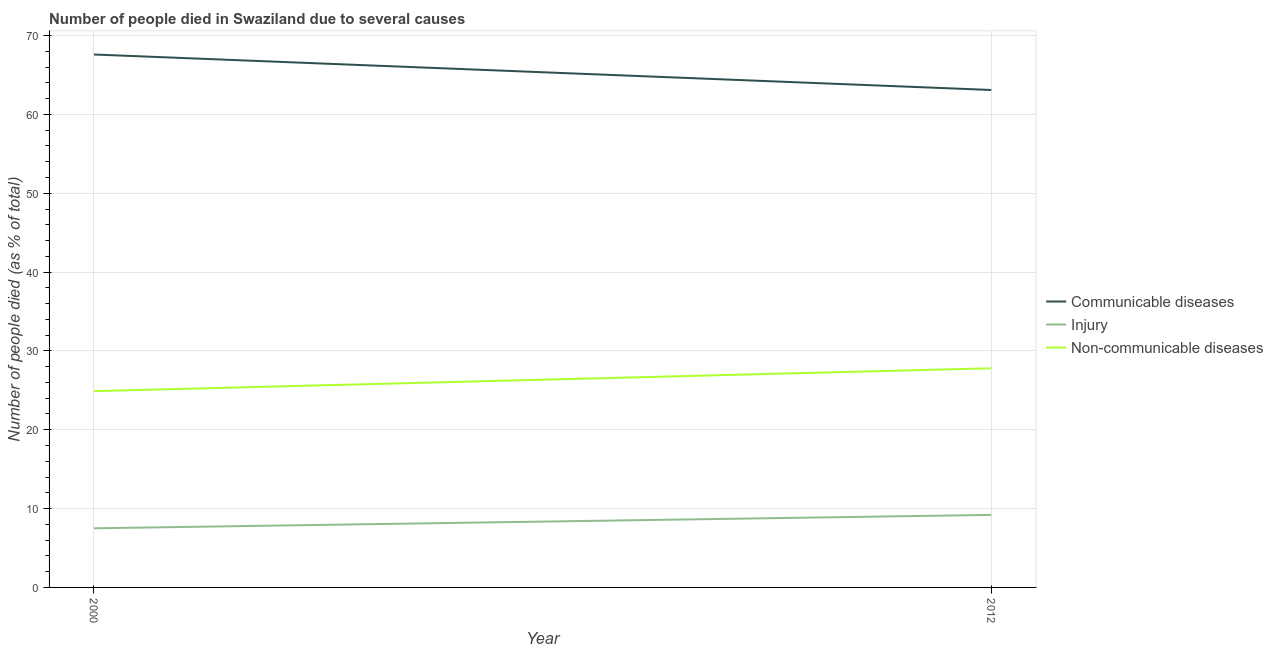Does the line corresponding to number of people who died of injury intersect with the line corresponding to number of people who died of communicable diseases?
Make the answer very short. No. Across all years, what is the maximum number of people who died of communicable diseases?
Provide a succinct answer. 67.6. Across all years, what is the minimum number of people who died of communicable diseases?
Provide a short and direct response. 63.1. In which year was the number of people who died of communicable diseases maximum?
Offer a very short reply. 2000. What is the total number of people who dies of non-communicable diseases in the graph?
Your response must be concise. 52.7. What is the difference between the number of people who died of communicable diseases in 2000 and that in 2012?
Your answer should be compact. 4.5. What is the difference between the number of people who dies of non-communicable diseases in 2012 and the number of people who died of communicable diseases in 2000?
Your response must be concise. -39.8. What is the average number of people who died of communicable diseases per year?
Provide a short and direct response. 65.35. In the year 2012, what is the difference between the number of people who died of injury and number of people who dies of non-communicable diseases?
Provide a short and direct response. -18.6. What is the ratio of the number of people who died of injury in 2000 to that in 2012?
Your response must be concise. 0.82. Does the number of people who died of communicable diseases monotonically increase over the years?
Keep it short and to the point. No. Is the number of people who died of injury strictly less than the number of people who died of communicable diseases over the years?
Give a very brief answer. Yes. How many years are there in the graph?
Your answer should be very brief. 2. What is the difference between two consecutive major ticks on the Y-axis?
Ensure brevity in your answer.  10. Are the values on the major ticks of Y-axis written in scientific E-notation?
Give a very brief answer. No. Where does the legend appear in the graph?
Keep it short and to the point. Center right. How many legend labels are there?
Keep it short and to the point. 3. What is the title of the graph?
Your response must be concise. Number of people died in Swaziland due to several causes. What is the label or title of the Y-axis?
Your response must be concise. Number of people died (as % of total). What is the Number of people died (as % of total) in Communicable diseases in 2000?
Your response must be concise. 67.6. What is the Number of people died (as % of total) of Non-communicable diseases in 2000?
Your response must be concise. 24.9. What is the Number of people died (as % of total) in Communicable diseases in 2012?
Your response must be concise. 63.1. What is the Number of people died (as % of total) in Injury in 2012?
Your answer should be compact. 9.2. What is the Number of people died (as % of total) of Non-communicable diseases in 2012?
Your answer should be very brief. 27.8. Across all years, what is the maximum Number of people died (as % of total) in Communicable diseases?
Offer a very short reply. 67.6. Across all years, what is the maximum Number of people died (as % of total) of Non-communicable diseases?
Offer a very short reply. 27.8. Across all years, what is the minimum Number of people died (as % of total) of Communicable diseases?
Keep it short and to the point. 63.1. Across all years, what is the minimum Number of people died (as % of total) in Non-communicable diseases?
Offer a terse response. 24.9. What is the total Number of people died (as % of total) of Communicable diseases in the graph?
Your answer should be very brief. 130.7. What is the total Number of people died (as % of total) in Injury in the graph?
Make the answer very short. 16.7. What is the total Number of people died (as % of total) of Non-communicable diseases in the graph?
Your response must be concise. 52.7. What is the difference between the Number of people died (as % of total) of Communicable diseases in 2000 and the Number of people died (as % of total) of Injury in 2012?
Offer a terse response. 58.4. What is the difference between the Number of people died (as % of total) of Communicable diseases in 2000 and the Number of people died (as % of total) of Non-communicable diseases in 2012?
Ensure brevity in your answer.  39.8. What is the difference between the Number of people died (as % of total) of Injury in 2000 and the Number of people died (as % of total) of Non-communicable diseases in 2012?
Provide a succinct answer. -20.3. What is the average Number of people died (as % of total) in Communicable diseases per year?
Keep it short and to the point. 65.35. What is the average Number of people died (as % of total) in Injury per year?
Your answer should be compact. 8.35. What is the average Number of people died (as % of total) in Non-communicable diseases per year?
Provide a short and direct response. 26.35. In the year 2000, what is the difference between the Number of people died (as % of total) in Communicable diseases and Number of people died (as % of total) in Injury?
Keep it short and to the point. 60.1. In the year 2000, what is the difference between the Number of people died (as % of total) in Communicable diseases and Number of people died (as % of total) in Non-communicable diseases?
Give a very brief answer. 42.7. In the year 2000, what is the difference between the Number of people died (as % of total) of Injury and Number of people died (as % of total) of Non-communicable diseases?
Provide a short and direct response. -17.4. In the year 2012, what is the difference between the Number of people died (as % of total) of Communicable diseases and Number of people died (as % of total) of Injury?
Your answer should be very brief. 53.9. In the year 2012, what is the difference between the Number of people died (as % of total) of Communicable diseases and Number of people died (as % of total) of Non-communicable diseases?
Your answer should be very brief. 35.3. In the year 2012, what is the difference between the Number of people died (as % of total) in Injury and Number of people died (as % of total) in Non-communicable diseases?
Make the answer very short. -18.6. What is the ratio of the Number of people died (as % of total) in Communicable diseases in 2000 to that in 2012?
Offer a terse response. 1.07. What is the ratio of the Number of people died (as % of total) in Injury in 2000 to that in 2012?
Offer a very short reply. 0.82. What is the ratio of the Number of people died (as % of total) of Non-communicable diseases in 2000 to that in 2012?
Offer a very short reply. 0.9. What is the difference between the highest and the second highest Number of people died (as % of total) of Injury?
Offer a very short reply. 1.7. What is the difference between the highest and the second highest Number of people died (as % of total) of Non-communicable diseases?
Your answer should be compact. 2.9. 